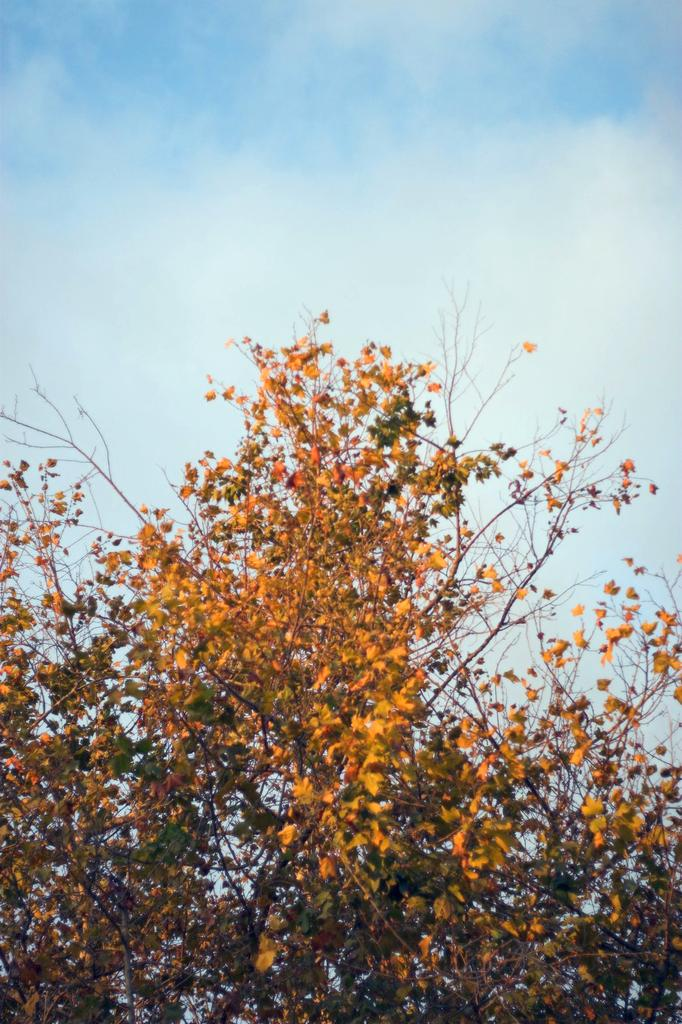What type of vegetation can be seen in the image? There are branches of trees with leaves in the image. What is visible in the background of the image? There is sky visible in the background of the image. What can be observed in the sky? Clouds are present in the sky. What type of slave is depicted in the image? There is no slave present in the image; it features branches of trees with leaves and a sky with clouds. What kind of badge can be seen on the tree branches? There is no badge present on the tree branches in the image. 